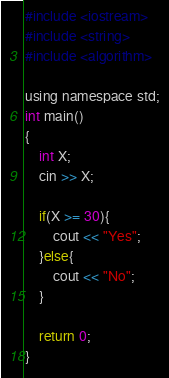<code> <loc_0><loc_0><loc_500><loc_500><_Python_>#include <iostream>
#include <string>
#include <algorithm>

using namespace std;
int main()
{
    int X;
    cin >> X;

    if(X >= 30){
        cout << "Yes";
    }else{
        cout << "No";
    }

    return 0;
}</code> 